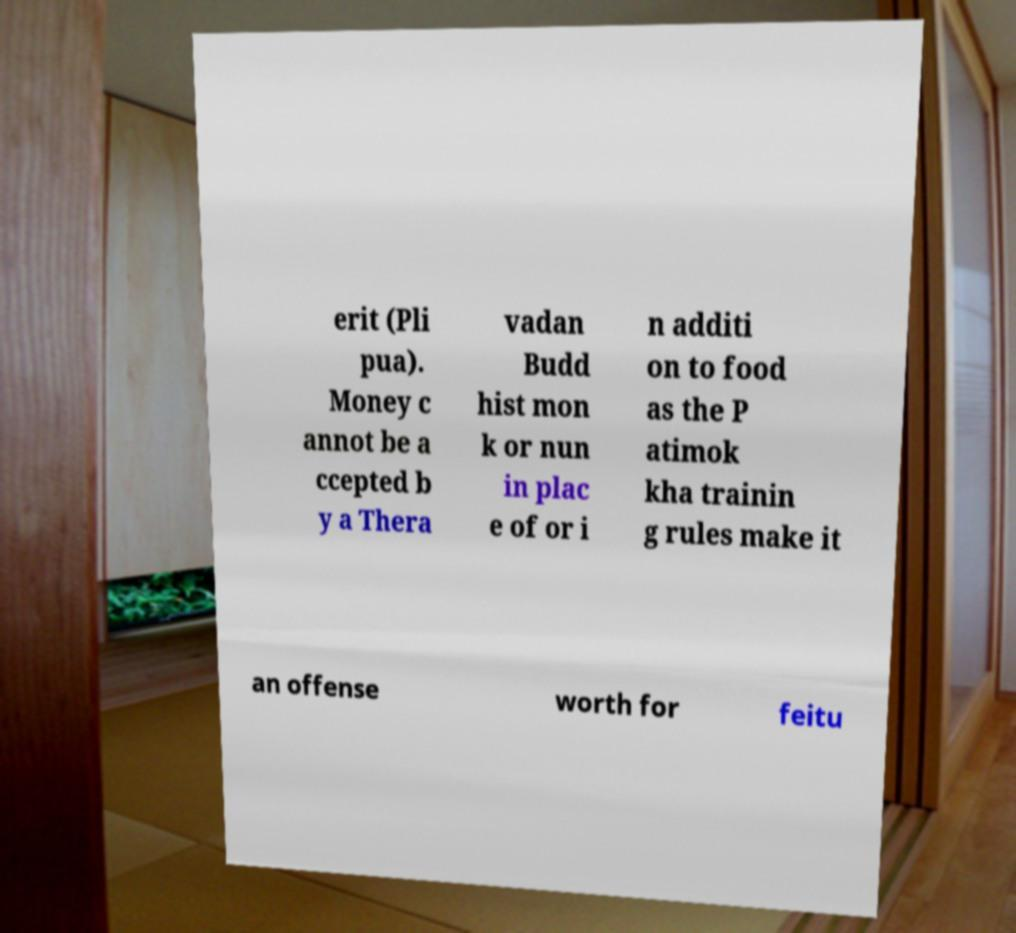There's text embedded in this image that I need extracted. Can you transcribe it verbatim? erit (Pli pua). Money c annot be a ccepted b y a Thera vadan Budd hist mon k or nun in plac e of or i n additi on to food as the P atimok kha trainin g rules make it an offense worth for feitu 